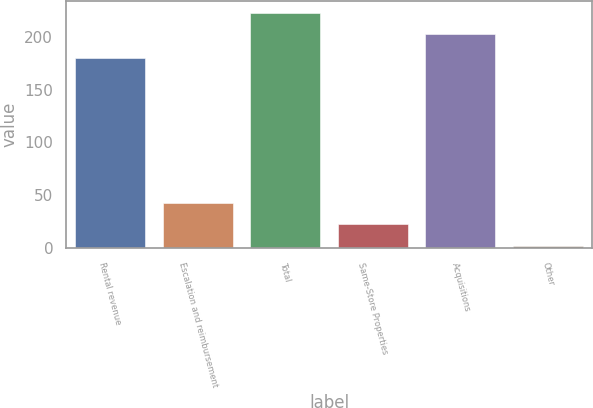<chart> <loc_0><loc_0><loc_500><loc_500><bar_chart><fcel>Rental revenue<fcel>Escalation and reimbursement<fcel>Total<fcel>Same-Store Properties<fcel>Acquisitions<fcel>Other<nl><fcel>179.4<fcel>43.04<fcel>222.67<fcel>22.57<fcel>202.2<fcel>2.1<nl></chart> 